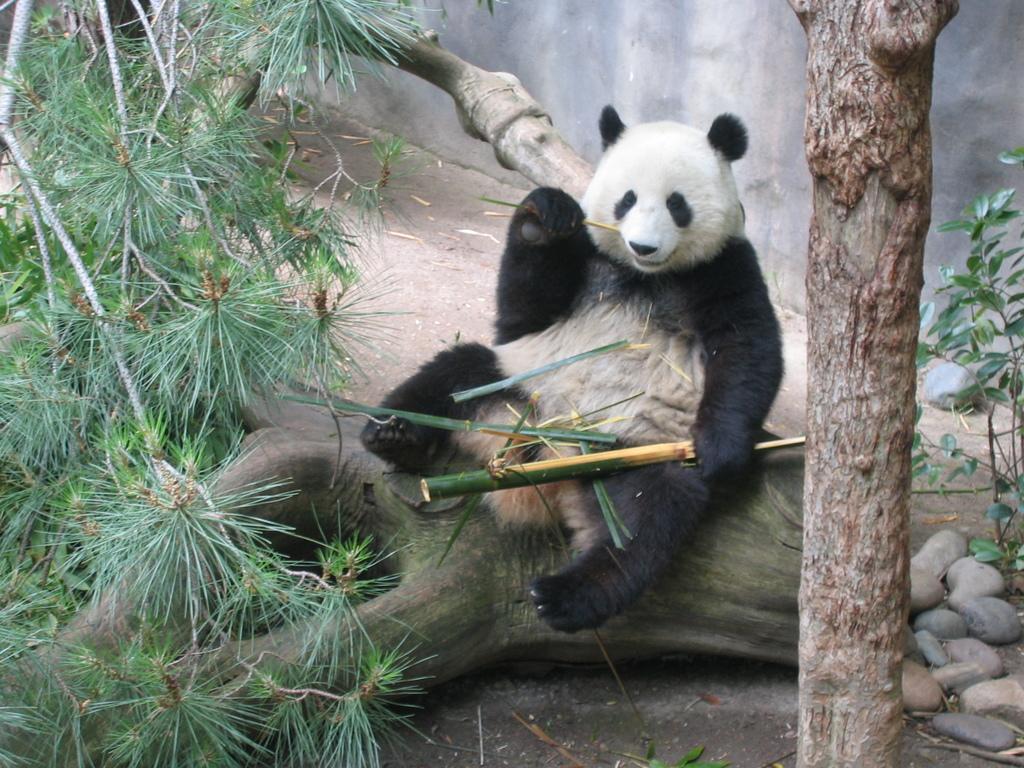Can you describe this image briefly? In this image I can see a panda is sitting on the bark of a tree. On the left side there are trees, on the right side there are stones. 